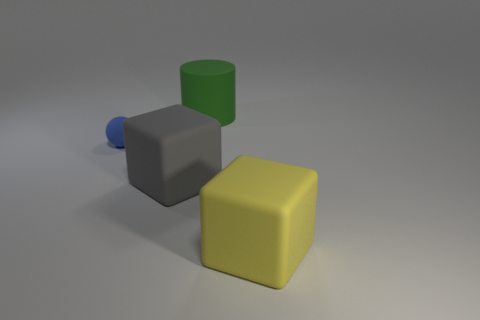Add 2 rubber blocks. How many objects exist? 6 Subtract all cylinders. How many objects are left? 3 Subtract all big gray rubber objects. Subtract all tiny blue spheres. How many objects are left? 2 Add 1 small blue rubber balls. How many small blue rubber balls are left? 2 Add 1 gray matte things. How many gray matte things exist? 2 Subtract 0 brown cylinders. How many objects are left? 4 